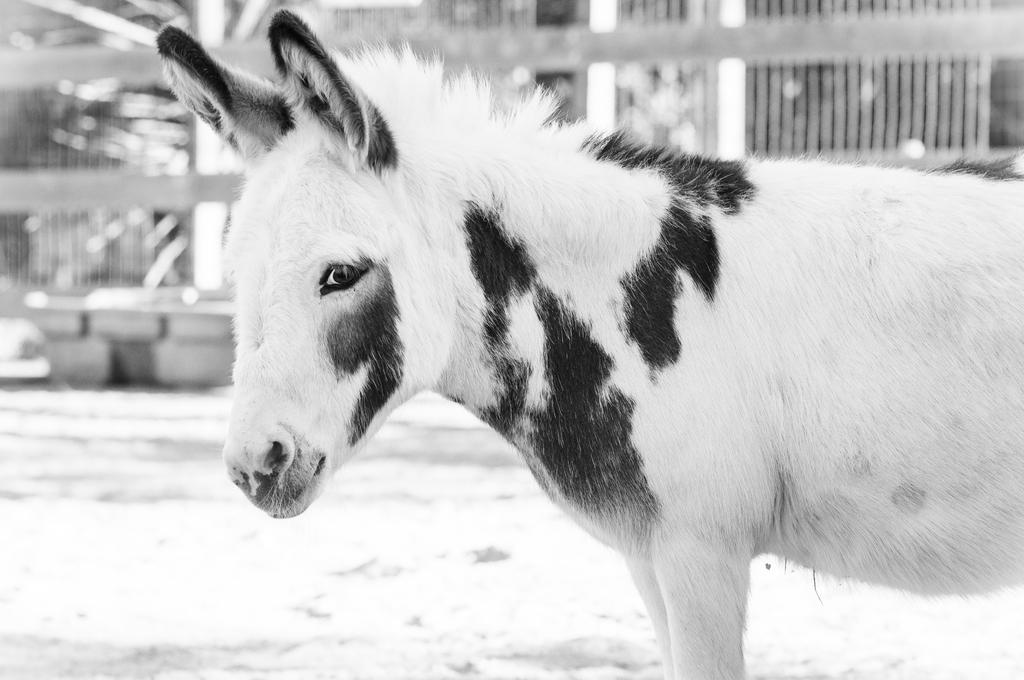What is the color scheme of the image? The image is black and white. What type of living creature can be seen in the image? There is an animal in the image. How would you describe the background of the image? The background of the image is blurred. What can be seen in the background of the image besides the blurred area? Plants and other objects are visible in the background of the image. What is the noise level of the railway in the image? There is no railway present in the image, so it is not possible to determine the noise level. 